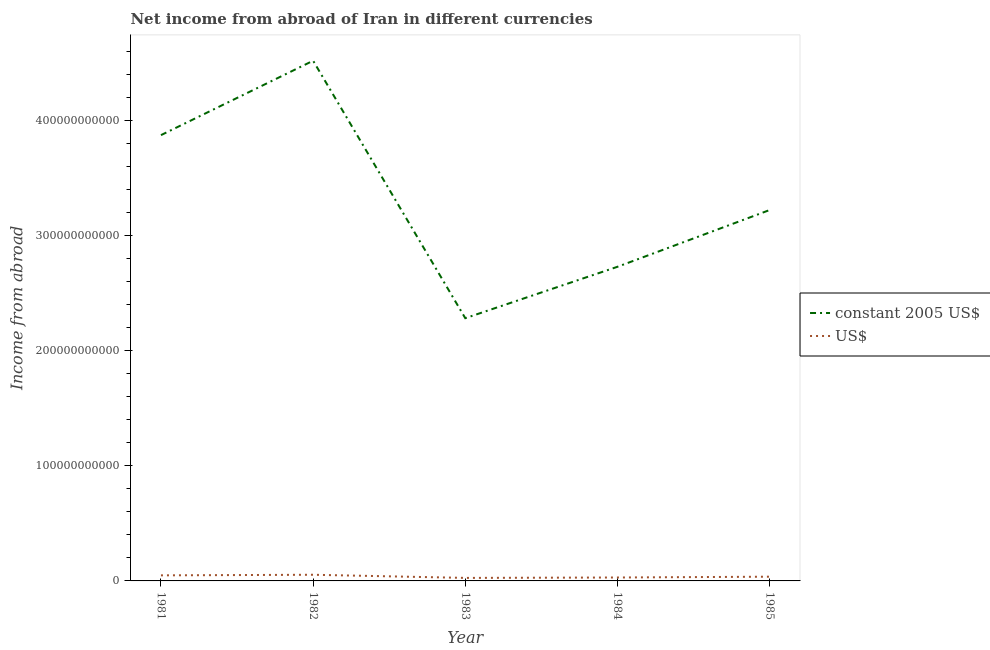How many different coloured lines are there?
Offer a very short reply. 2. Is the number of lines equal to the number of legend labels?
Keep it short and to the point. Yes. What is the income from abroad in constant 2005 us$ in 1982?
Offer a terse response. 4.52e+11. Across all years, what is the maximum income from abroad in us$?
Your answer should be compact. 5.35e+09. Across all years, what is the minimum income from abroad in us$?
Give a very brief answer. 2.62e+09. What is the total income from abroad in constant 2005 us$ in the graph?
Make the answer very short. 1.66e+12. What is the difference between the income from abroad in constant 2005 us$ in 1981 and that in 1982?
Keep it short and to the point. -6.47e+1. What is the difference between the income from abroad in constant 2005 us$ in 1981 and the income from abroad in us$ in 1984?
Your response must be concise. 3.84e+11. What is the average income from abroad in us$ per year?
Your response must be concise. 3.89e+09. In the year 1982, what is the difference between the income from abroad in us$ and income from abroad in constant 2005 us$?
Your response must be concise. -4.47e+11. In how many years, is the income from abroad in constant 2005 us$ greater than 120000000000 units?
Provide a succinct answer. 5. What is the ratio of the income from abroad in constant 2005 us$ in 1981 to that in 1983?
Your answer should be very brief. 1.7. Is the income from abroad in us$ in 1983 less than that in 1985?
Offer a very short reply. Yes. Is the difference between the income from abroad in constant 2005 us$ in 1981 and 1983 greater than the difference between the income from abroad in us$ in 1981 and 1983?
Give a very brief answer. Yes. What is the difference between the highest and the second highest income from abroad in constant 2005 us$?
Ensure brevity in your answer.  6.47e+1. What is the difference between the highest and the lowest income from abroad in us$?
Keep it short and to the point. 2.74e+09. In how many years, is the income from abroad in us$ greater than the average income from abroad in us$ taken over all years?
Ensure brevity in your answer.  2. Is the sum of the income from abroad in constant 2005 us$ in 1984 and 1985 greater than the maximum income from abroad in us$ across all years?
Ensure brevity in your answer.  Yes. Does the income from abroad in us$ monotonically increase over the years?
Make the answer very short. No. Is the income from abroad in us$ strictly greater than the income from abroad in constant 2005 us$ over the years?
Ensure brevity in your answer.  No. Is the income from abroad in us$ strictly less than the income from abroad in constant 2005 us$ over the years?
Ensure brevity in your answer.  Yes. How many lines are there?
Your response must be concise. 2. How many years are there in the graph?
Provide a short and direct response. 5. What is the difference between two consecutive major ticks on the Y-axis?
Your answer should be compact. 1.00e+11. Are the values on the major ticks of Y-axis written in scientific E-notation?
Give a very brief answer. No. Does the graph contain any zero values?
Ensure brevity in your answer.  No. How are the legend labels stacked?
Provide a short and direct response. Vertical. What is the title of the graph?
Offer a terse response. Net income from abroad of Iran in different currencies. Does "National Visitors" appear as one of the legend labels in the graph?
Provide a short and direct response. No. What is the label or title of the X-axis?
Make the answer very short. Year. What is the label or title of the Y-axis?
Ensure brevity in your answer.  Income from abroad. What is the Income from abroad in constant 2005 US$ in 1981?
Your response must be concise. 3.87e+11. What is the Income from abroad in US$ in 1981?
Provide a succinct answer. 4.84e+09. What is the Income from abroad of constant 2005 US$ in 1982?
Your answer should be very brief. 4.52e+11. What is the Income from abroad in US$ in 1982?
Your answer should be very brief. 5.35e+09. What is the Income from abroad of constant 2005 US$ in 1983?
Your answer should be very brief. 2.28e+11. What is the Income from abroad in US$ in 1983?
Keep it short and to the point. 2.62e+09. What is the Income from abroad of constant 2005 US$ in 1984?
Make the answer very short. 2.73e+11. What is the Income from abroad of US$ in 1984?
Provide a succinct answer. 2.97e+09. What is the Income from abroad of constant 2005 US$ in 1985?
Your answer should be very brief. 3.22e+11. What is the Income from abroad of US$ in 1985?
Provide a short and direct response. 3.67e+09. Across all years, what is the maximum Income from abroad of constant 2005 US$?
Offer a very short reply. 4.52e+11. Across all years, what is the maximum Income from abroad in US$?
Offer a terse response. 5.35e+09. Across all years, what is the minimum Income from abroad in constant 2005 US$?
Your response must be concise. 2.28e+11. Across all years, what is the minimum Income from abroad in US$?
Make the answer very short. 2.62e+09. What is the total Income from abroad of constant 2005 US$ in the graph?
Keep it short and to the point. 1.66e+12. What is the total Income from abroad in US$ in the graph?
Your response must be concise. 1.95e+1. What is the difference between the Income from abroad in constant 2005 US$ in 1981 and that in 1982?
Your response must be concise. -6.47e+1. What is the difference between the Income from abroad in US$ in 1981 and that in 1982?
Make the answer very short. -5.12e+08. What is the difference between the Income from abroad in constant 2005 US$ in 1981 and that in 1983?
Provide a short and direct response. 1.59e+11. What is the difference between the Income from abroad of US$ in 1981 and that in 1983?
Your answer should be very brief. 2.22e+09. What is the difference between the Income from abroad of constant 2005 US$ in 1981 and that in 1984?
Give a very brief answer. 1.14e+11. What is the difference between the Income from abroad of US$ in 1981 and that in 1984?
Ensure brevity in your answer.  1.87e+09. What is the difference between the Income from abroad of constant 2005 US$ in 1981 and that in 1985?
Provide a succinct answer. 6.51e+1. What is the difference between the Income from abroad of US$ in 1981 and that in 1985?
Offer a terse response. 1.17e+09. What is the difference between the Income from abroad of constant 2005 US$ in 1982 and that in 1983?
Offer a terse response. 2.24e+11. What is the difference between the Income from abroad of US$ in 1982 and that in 1983?
Your answer should be very brief. 2.74e+09. What is the difference between the Income from abroad in constant 2005 US$ in 1982 and that in 1984?
Offer a terse response. 1.79e+11. What is the difference between the Income from abroad of US$ in 1982 and that in 1984?
Offer a terse response. 2.38e+09. What is the difference between the Income from abroad of constant 2005 US$ in 1982 and that in 1985?
Provide a short and direct response. 1.30e+11. What is the difference between the Income from abroad of US$ in 1982 and that in 1985?
Give a very brief answer. 1.68e+09. What is the difference between the Income from abroad of constant 2005 US$ in 1983 and that in 1984?
Your answer should be compact. -4.47e+1. What is the difference between the Income from abroad in US$ in 1983 and that in 1984?
Keep it short and to the point. -3.53e+08. What is the difference between the Income from abroad of constant 2005 US$ in 1983 and that in 1985?
Ensure brevity in your answer.  -9.40e+1. What is the difference between the Income from abroad of US$ in 1983 and that in 1985?
Keep it short and to the point. -1.06e+09. What is the difference between the Income from abroad in constant 2005 US$ in 1984 and that in 1985?
Ensure brevity in your answer.  -4.93e+1. What is the difference between the Income from abroad in US$ in 1984 and that in 1985?
Offer a terse response. -7.03e+08. What is the difference between the Income from abroad in constant 2005 US$ in 1981 and the Income from abroad in US$ in 1982?
Provide a succinct answer. 3.82e+11. What is the difference between the Income from abroad of constant 2005 US$ in 1981 and the Income from abroad of US$ in 1983?
Make the answer very short. 3.85e+11. What is the difference between the Income from abroad of constant 2005 US$ in 1981 and the Income from abroad of US$ in 1984?
Keep it short and to the point. 3.84e+11. What is the difference between the Income from abroad in constant 2005 US$ in 1981 and the Income from abroad in US$ in 1985?
Make the answer very short. 3.84e+11. What is the difference between the Income from abroad of constant 2005 US$ in 1982 and the Income from abroad of US$ in 1983?
Give a very brief answer. 4.49e+11. What is the difference between the Income from abroad in constant 2005 US$ in 1982 and the Income from abroad in US$ in 1984?
Your answer should be very brief. 4.49e+11. What is the difference between the Income from abroad of constant 2005 US$ in 1982 and the Income from abroad of US$ in 1985?
Provide a short and direct response. 4.48e+11. What is the difference between the Income from abroad in constant 2005 US$ in 1983 and the Income from abroad in US$ in 1984?
Offer a terse response. 2.25e+11. What is the difference between the Income from abroad in constant 2005 US$ in 1983 and the Income from abroad in US$ in 1985?
Keep it short and to the point. 2.25e+11. What is the difference between the Income from abroad in constant 2005 US$ in 1984 and the Income from abroad in US$ in 1985?
Keep it short and to the point. 2.69e+11. What is the average Income from abroad in constant 2005 US$ per year?
Keep it short and to the point. 3.33e+11. What is the average Income from abroad of US$ per year?
Your answer should be very brief. 3.89e+09. In the year 1981, what is the difference between the Income from abroad of constant 2005 US$ and Income from abroad of US$?
Your answer should be compact. 3.83e+11. In the year 1982, what is the difference between the Income from abroad in constant 2005 US$ and Income from abroad in US$?
Offer a terse response. 4.47e+11. In the year 1983, what is the difference between the Income from abroad of constant 2005 US$ and Income from abroad of US$?
Ensure brevity in your answer.  2.26e+11. In the year 1984, what is the difference between the Income from abroad in constant 2005 US$ and Income from abroad in US$?
Make the answer very short. 2.70e+11. In the year 1985, what is the difference between the Income from abroad of constant 2005 US$ and Income from abroad of US$?
Offer a terse response. 3.19e+11. What is the ratio of the Income from abroad in constant 2005 US$ in 1981 to that in 1982?
Your answer should be very brief. 0.86. What is the ratio of the Income from abroad in US$ in 1981 to that in 1982?
Provide a short and direct response. 0.9. What is the ratio of the Income from abroad in constant 2005 US$ in 1981 to that in 1983?
Your response must be concise. 1.7. What is the ratio of the Income from abroad in US$ in 1981 to that in 1983?
Provide a succinct answer. 1.85. What is the ratio of the Income from abroad in constant 2005 US$ in 1981 to that in 1984?
Provide a short and direct response. 1.42. What is the ratio of the Income from abroad of US$ in 1981 to that in 1984?
Your response must be concise. 1.63. What is the ratio of the Income from abroad in constant 2005 US$ in 1981 to that in 1985?
Give a very brief answer. 1.2. What is the ratio of the Income from abroad of US$ in 1981 to that in 1985?
Your response must be concise. 1.32. What is the ratio of the Income from abroad of constant 2005 US$ in 1982 to that in 1983?
Your answer should be compact. 1.98. What is the ratio of the Income from abroad in US$ in 1982 to that in 1983?
Provide a succinct answer. 2.04. What is the ratio of the Income from abroad of constant 2005 US$ in 1982 to that in 1984?
Your response must be concise. 1.66. What is the ratio of the Income from abroad of US$ in 1982 to that in 1984?
Your answer should be very brief. 1.8. What is the ratio of the Income from abroad of constant 2005 US$ in 1982 to that in 1985?
Your answer should be compact. 1.4. What is the ratio of the Income from abroad in US$ in 1982 to that in 1985?
Provide a short and direct response. 1.46. What is the ratio of the Income from abroad in constant 2005 US$ in 1983 to that in 1984?
Offer a very short reply. 0.84. What is the ratio of the Income from abroad in US$ in 1983 to that in 1984?
Provide a succinct answer. 0.88. What is the ratio of the Income from abroad in constant 2005 US$ in 1983 to that in 1985?
Ensure brevity in your answer.  0.71. What is the ratio of the Income from abroad of US$ in 1983 to that in 1985?
Offer a very short reply. 0.71. What is the ratio of the Income from abroad in constant 2005 US$ in 1984 to that in 1985?
Your answer should be very brief. 0.85. What is the ratio of the Income from abroad in US$ in 1984 to that in 1985?
Your response must be concise. 0.81. What is the difference between the highest and the second highest Income from abroad in constant 2005 US$?
Your answer should be compact. 6.47e+1. What is the difference between the highest and the second highest Income from abroad of US$?
Your response must be concise. 5.12e+08. What is the difference between the highest and the lowest Income from abroad in constant 2005 US$?
Provide a succinct answer. 2.24e+11. What is the difference between the highest and the lowest Income from abroad in US$?
Your response must be concise. 2.74e+09. 